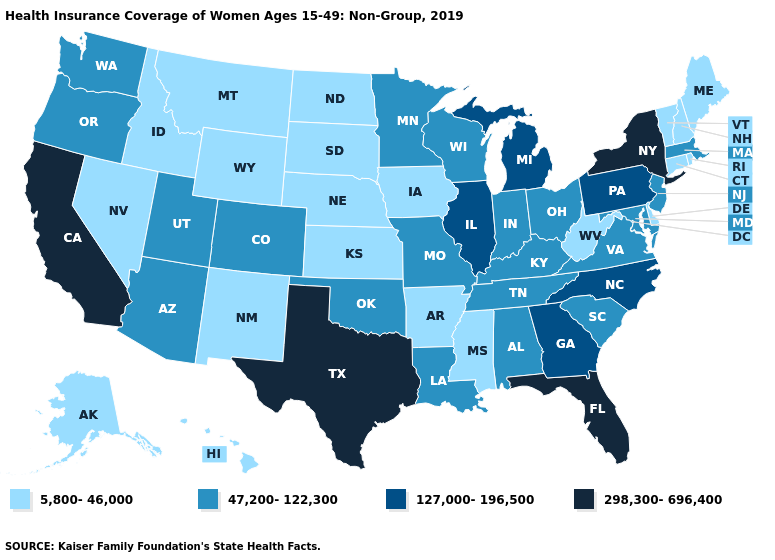Among the states that border Missouri , does Kentucky have the highest value?
Give a very brief answer. No. Does Mississippi have a lower value than Iowa?
Be succinct. No. Which states have the lowest value in the USA?
Quick response, please. Alaska, Arkansas, Connecticut, Delaware, Hawaii, Idaho, Iowa, Kansas, Maine, Mississippi, Montana, Nebraska, Nevada, New Hampshire, New Mexico, North Dakota, Rhode Island, South Dakota, Vermont, West Virginia, Wyoming. Does Illinois have the highest value in the MidWest?
Be succinct. Yes. How many symbols are there in the legend?
Short answer required. 4. What is the value of Kansas?
Be succinct. 5,800-46,000. Name the states that have a value in the range 5,800-46,000?
Write a very short answer. Alaska, Arkansas, Connecticut, Delaware, Hawaii, Idaho, Iowa, Kansas, Maine, Mississippi, Montana, Nebraska, Nevada, New Hampshire, New Mexico, North Dakota, Rhode Island, South Dakota, Vermont, West Virginia, Wyoming. Which states hav the highest value in the Northeast?
Answer briefly. New York. Does Ohio have the highest value in the USA?
Keep it brief. No. Name the states that have a value in the range 127,000-196,500?
Give a very brief answer. Georgia, Illinois, Michigan, North Carolina, Pennsylvania. Among the states that border New Hampshire , does Massachusetts have the lowest value?
Quick response, please. No. Among the states that border Maine , which have the highest value?
Write a very short answer. New Hampshire. Is the legend a continuous bar?
Give a very brief answer. No. What is the value of Michigan?
Concise answer only. 127,000-196,500. Does Connecticut have the lowest value in the USA?
Concise answer only. Yes. 